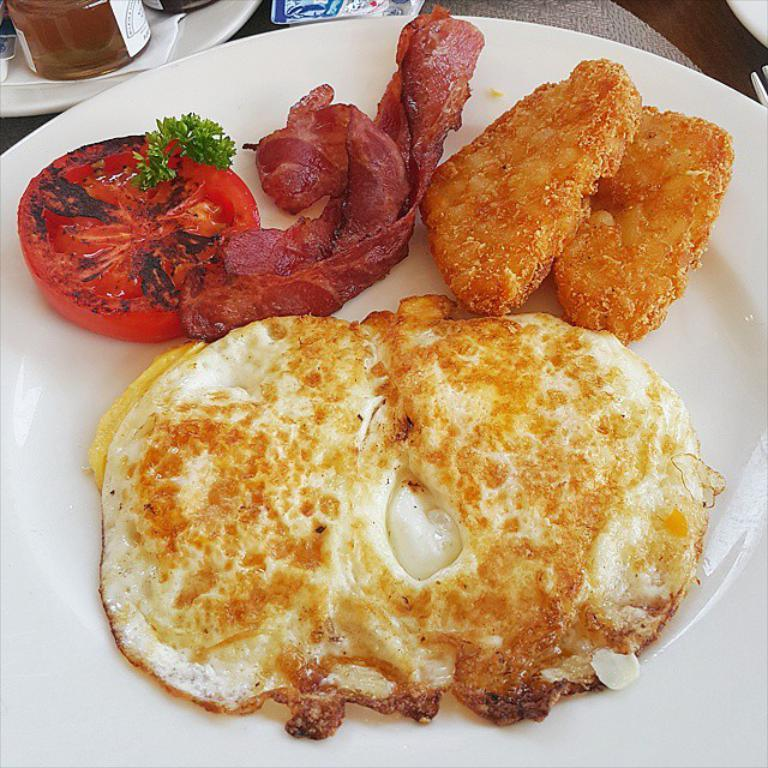What is on the plate in the image? There is food in a plate in the image. What else can be seen in the image besides the plate? There is a bottle, tissue papers, and a fork in the image. Where are these items placed? All of these items are placed on a surface. What color is the paint on the notebook in the image? There is no paint or notebook present in the image. 